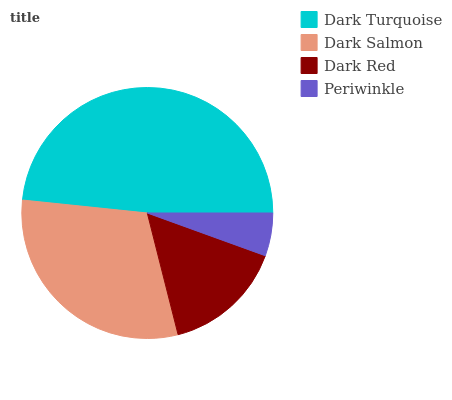Is Periwinkle the minimum?
Answer yes or no. Yes. Is Dark Turquoise the maximum?
Answer yes or no. Yes. Is Dark Salmon the minimum?
Answer yes or no. No. Is Dark Salmon the maximum?
Answer yes or no. No. Is Dark Turquoise greater than Dark Salmon?
Answer yes or no. Yes. Is Dark Salmon less than Dark Turquoise?
Answer yes or no. Yes. Is Dark Salmon greater than Dark Turquoise?
Answer yes or no. No. Is Dark Turquoise less than Dark Salmon?
Answer yes or no. No. Is Dark Salmon the high median?
Answer yes or no. Yes. Is Dark Red the low median?
Answer yes or no. Yes. Is Periwinkle the high median?
Answer yes or no. No. Is Dark Turquoise the low median?
Answer yes or no. No. 